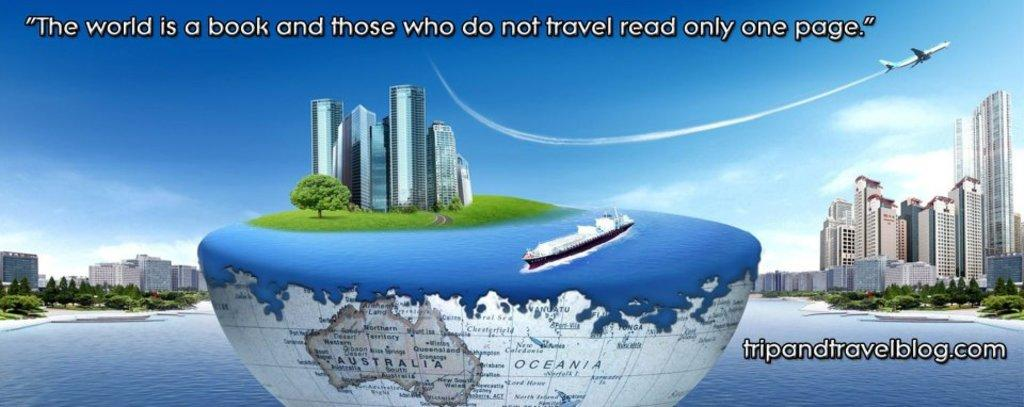<image>
Provide a brief description of the given image. Half a globe has Australia visible on the bottom and a cruise ship on top. 